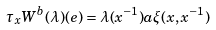<formula> <loc_0><loc_0><loc_500><loc_500>\tau _ { x } W ^ { b } ( \lambda ) ( e ) = \lambda ( x ^ { - 1 } ) a \xi ( x , x ^ { - 1 } )</formula> 